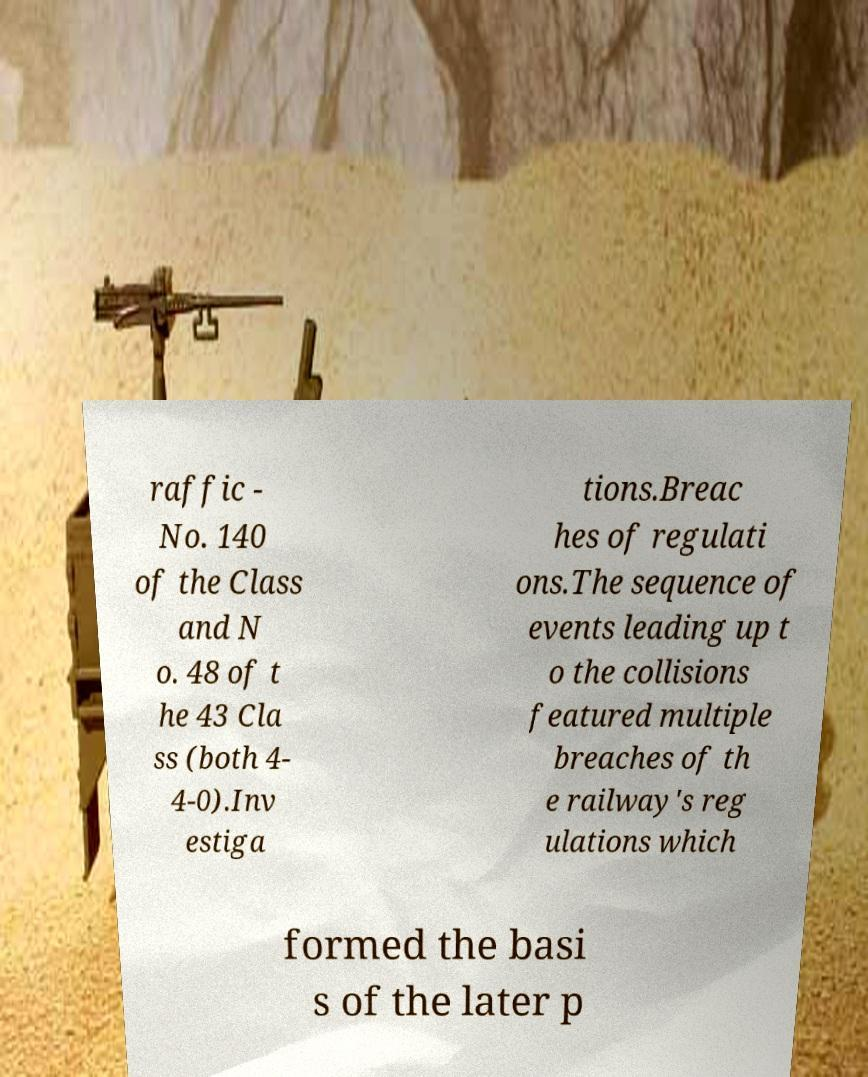Could you extract and type out the text from this image? raffic - No. 140 of the Class and N o. 48 of t he 43 Cla ss (both 4- 4-0).Inv estiga tions.Breac hes of regulati ons.The sequence of events leading up t o the collisions featured multiple breaches of th e railway's reg ulations which formed the basi s of the later p 